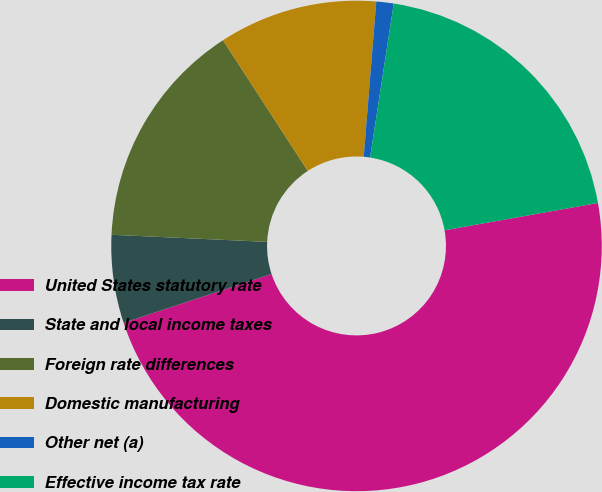Convert chart to OTSL. <chart><loc_0><loc_0><loc_500><loc_500><pie_chart><fcel>United States statutory rate<fcel>State and local income taxes<fcel>Foreign rate differences<fcel>Domestic manufacturing<fcel>Other net (a)<fcel>Effective income tax rate<nl><fcel>47.73%<fcel>5.8%<fcel>15.11%<fcel>10.45%<fcel>1.14%<fcel>19.77%<nl></chart> 